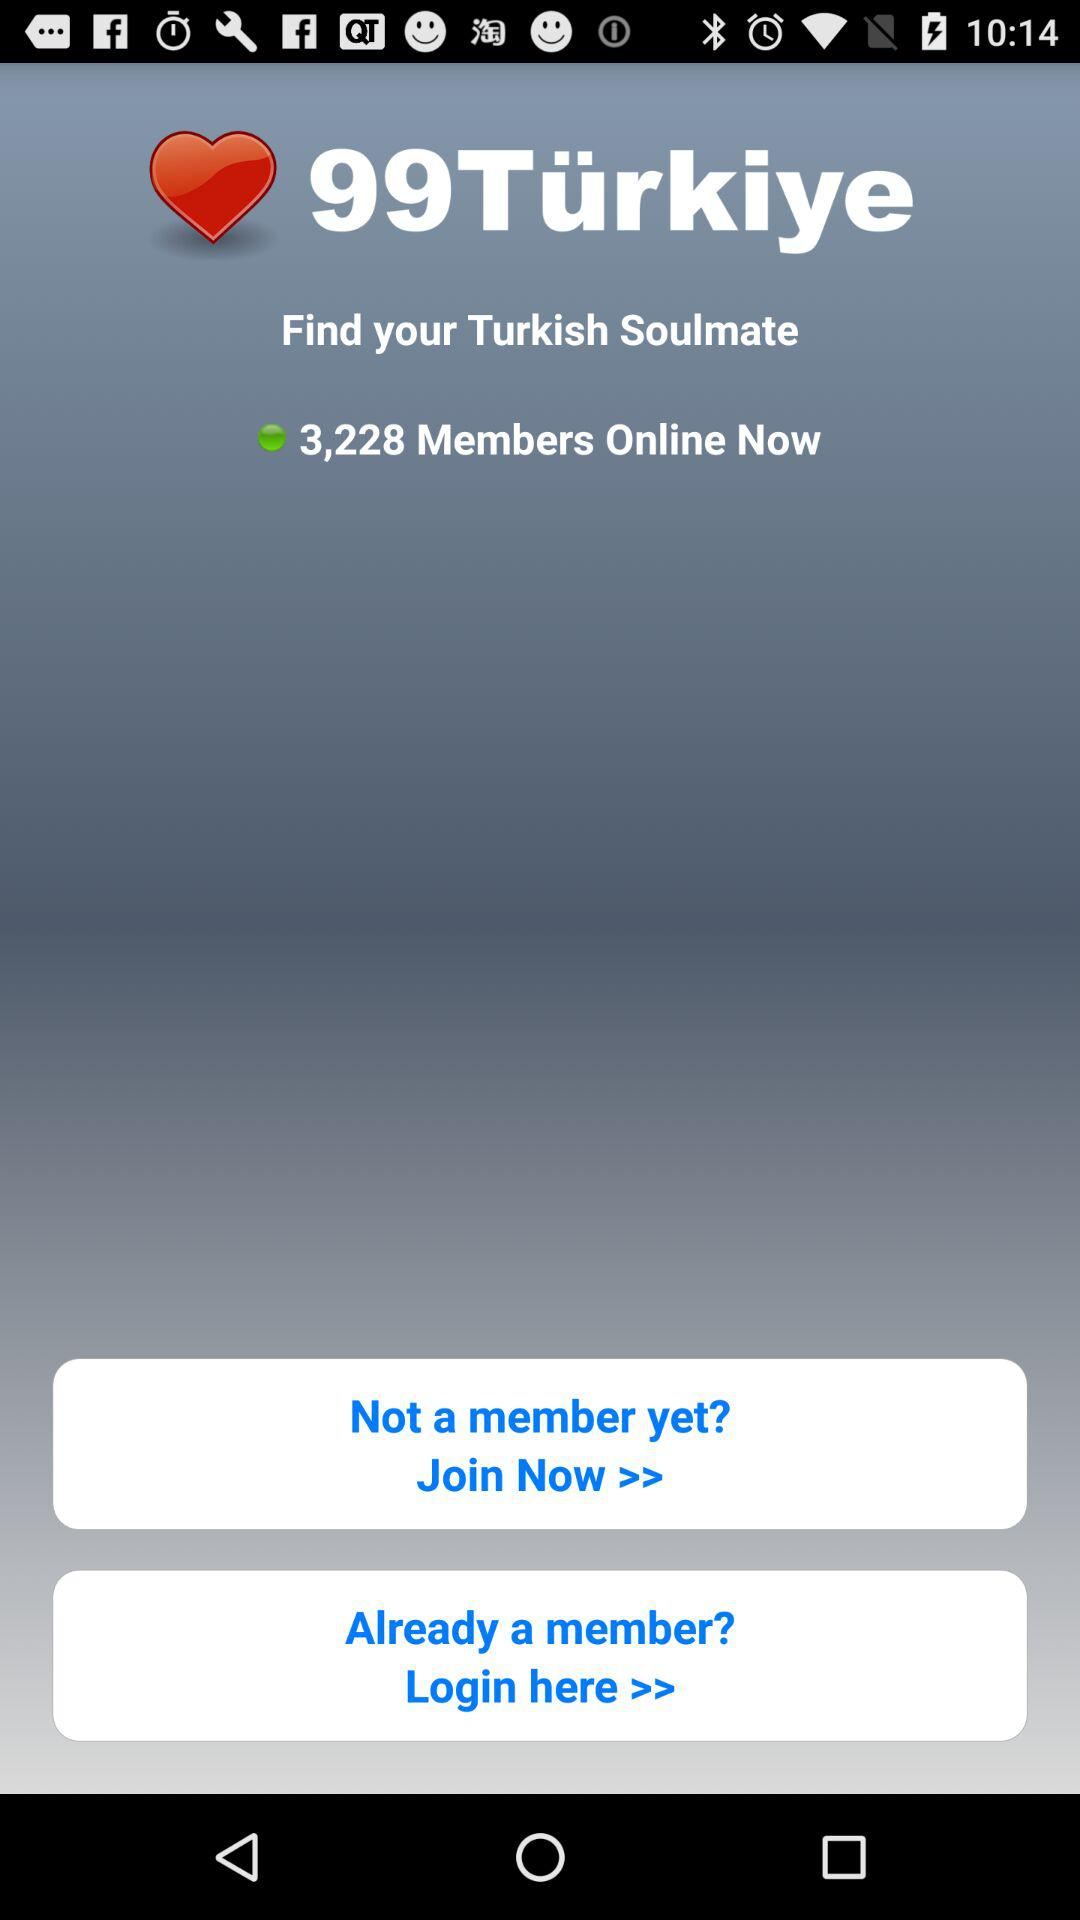What is the app name? The app name is "99Türkiye". 